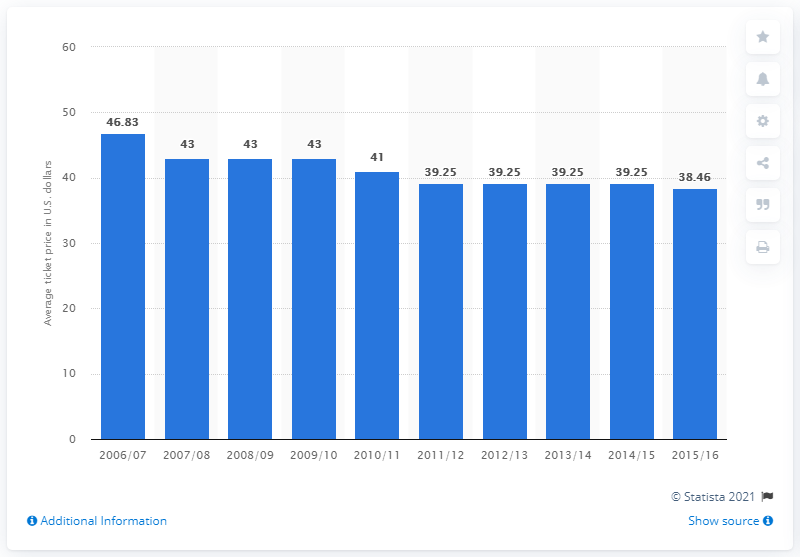List a handful of essential elements in this visual. The average ticket price for the Philadelphia 76ers games in the 2012/2013 season was 39.25 USD. In the 2006/07 season, the average ticket price was 46.83. The highest ticket price for a Philadelphia 76ers game between 2006 and 2015 was $8.37. 